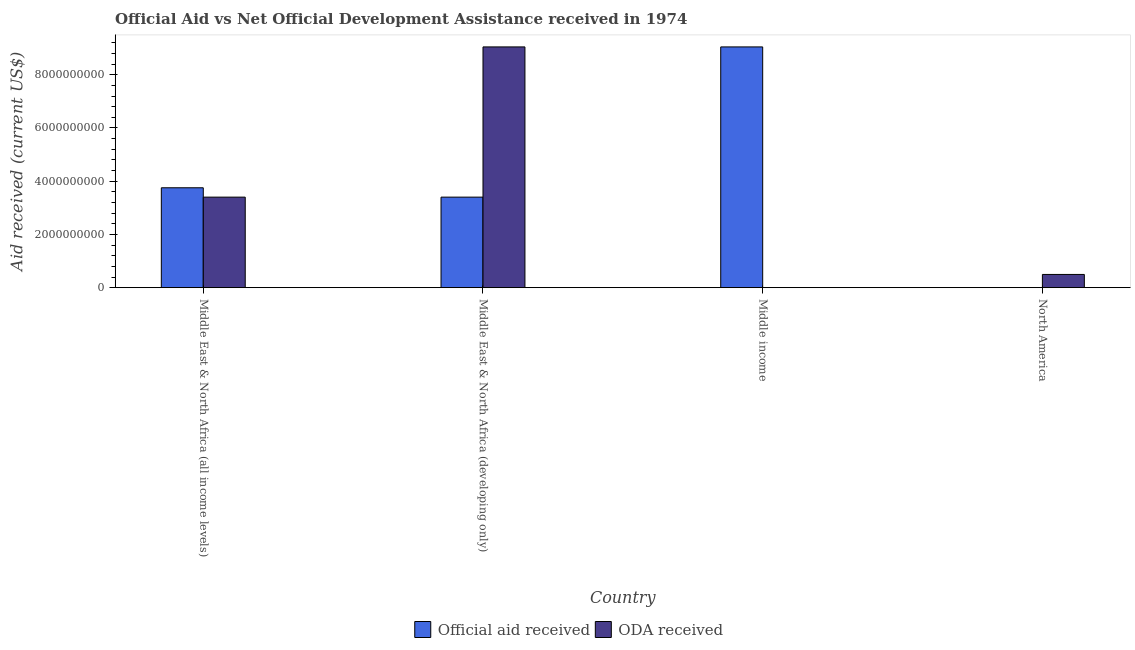How many bars are there on the 2nd tick from the left?
Provide a short and direct response. 2. How many bars are there on the 3rd tick from the right?
Provide a short and direct response. 2. What is the label of the 1st group of bars from the left?
Offer a terse response. Middle East & North Africa (all income levels). What is the oda received in Middle income?
Keep it short and to the point. 3.00e+04. Across all countries, what is the maximum oda received?
Provide a short and direct response. 9.05e+09. Across all countries, what is the minimum oda received?
Your answer should be compact. 3.00e+04. In which country was the oda received maximum?
Ensure brevity in your answer.  Middle East & North Africa (developing only). In which country was the official aid received minimum?
Offer a terse response. North America. What is the total oda received in the graph?
Make the answer very short. 1.29e+1. What is the difference between the official aid received in Middle East & North Africa (all income levels) and that in Middle income?
Ensure brevity in your answer.  -5.29e+09. What is the difference between the oda received in North America and the official aid received in Middle East & North Africa (all income levels)?
Give a very brief answer. -3.26e+09. What is the average official aid received per country?
Your answer should be very brief. 4.05e+09. What is the difference between the official aid received and oda received in North America?
Give a very brief answer. -4.96e+08. In how many countries, is the official aid received greater than 6400000000 US$?
Your answer should be very brief. 1. What is the ratio of the official aid received in Middle East & North Africa (all income levels) to that in Middle income?
Provide a succinct answer. 0.41. Is the difference between the oda received in Middle East & North Africa (all income levels) and Middle income greater than the difference between the official aid received in Middle East & North Africa (all income levels) and Middle income?
Give a very brief answer. Yes. What is the difference between the highest and the second highest official aid received?
Your answer should be compact. 5.29e+09. What is the difference between the highest and the lowest official aid received?
Provide a short and direct response. 9.05e+09. Is the sum of the oda received in Middle East & North Africa (all income levels) and North America greater than the maximum official aid received across all countries?
Provide a short and direct response. No. What does the 1st bar from the left in Middle East & North Africa (all income levels) represents?
Provide a short and direct response. Official aid received. What does the 2nd bar from the right in North America represents?
Your answer should be very brief. Official aid received. How many countries are there in the graph?
Offer a very short reply. 4. Does the graph contain grids?
Offer a very short reply. No. Where does the legend appear in the graph?
Keep it short and to the point. Bottom center. How many legend labels are there?
Offer a terse response. 2. What is the title of the graph?
Your answer should be very brief. Official Aid vs Net Official Development Assistance received in 1974 . Does "Non-solid fuel" appear as one of the legend labels in the graph?
Make the answer very short. No. What is the label or title of the X-axis?
Keep it short and to the point. Country. What is the label or title of the Y-axis?
Provide a succinct answer. Aid received (current US$). What is the Aid received (current US$) in Official aid received in Middle East & North Africa (all income levels)?
Your response must be concise. 3.75e+09. What is the Aid received (current US$) of ODA received in Middle East & North Africa (all income levels)?
Provide a succinct answer. 3.40e+09. What is the Aid received (current US$) of Official aid received in Middle East & North Africa (developing only)?
Offer a terse response. 3.40e+09. What is the Aid received (current US$) in ODA received in Middle East & North Africa (developing only)?
Offer a terse response. 9.05e+09. What is the Aid received (current US$) of Official aid received in Middle income?
Make the answer very short. 9.05e+09. What is the Aid received (current US$) of ODA received in North America?
Your response must be concise. 4.96e+08. Across all countries, what is the maximum Aid received (current US$) of Official aid received?
Offer a very short reply. 9.05e+09. Across all countries, what is the maximum Aid received (current US$) in ODA received?
Offer a terse response. 9.05e+09. What is the total Aid received (current US$) of Official aid received in the graph?
Your answer should be very brief. 1.62e+1. What is the total Aid received (current US$) in ODA received in the graph?
Your answer should be very brief. 1.29e+1. What is the difference between the Aid received (current US$) in Official aid received in Middle East & North Africa (all income levels) and that in Middle East & North Africa (developing only)?
Your answer should be very brief. 3.52e+08. What is the difference between the Aid received (current US$) in ODA received in Middle East & North Africa (all income levels) and that in Middle East & North Africa (developing only)?
Ensure brevity in your answer.  -5.64e+09. What is the difference between the Aid received (current US$) in Official aid received in Middle East & North Africa (all income levels) and that in Middle income?
Your answer should be very brief. -5.29e+09. What is the difference between the Aid received (current US$) of ODA received in Middle East & North Africa (all income levels) and that in Middle income?
Your answer should be compact. 3.40e+09. What is the difference between the Aid received (current US$) in Official aid received in Middle East & North Africa (all income levels) and that in North America?
Offer a terse response. 3.75e+09. What is the difference between the Aid received (current US$) in ODA received in Middle East & North Africa (all income levels) and that in North America?
Keep it short and to the point. 2.91e+09. What is the difference between the Aid received (current US$) in Official aid received in Middle East & North Africa (developing only) and that in Middle income?
Your answer should be very brief. -5.64e+09. What is the difference between the Aid received (current US$) in ODA received in Middle East & North Africa (developing only) and that in Middle income?
Keep it short and to the point. 9.05e+09. What is the difference between the Aid received (current US$) of Official aid received in Middle East & North Africa (developing only) and that in North America?
Your answer should be compact. 3.40e+09. What is the difference between the Aid received (current US$) in ODA received in Middle East & North Africa (developing only) and that in North America?
Ensure brevity in your answer.  8.55e+09. What is the difference between the Aid received (current US$) in Official aid received in Middle income and that in North America?
Your answer should be compact. 9.05e+09. What is the difference between the Aid received (current US$) of ODA received in Middle income and that in North America?
Your answer should be compact. -4.96e+08. What is the difference between the Aid received (current US$) of Official aid received in Middle East & North Africa (all income levels) and the Aid received (current US$) of ODA received in Middle East & North Africa (developing only)?
Keep it short and to the point. -5.29e+09. What is the difference between the Aid received (current US$) of Official aid received in Middle East & North Africa (all income levels) and the Aid received (current US$) of ODA received in Middle income?
Provide a succinct answer. 3.75e+09. What is the difference between the Aid received (current US$) of Official aid received in Middle East & North Africa (all income levels) and the Aid received (current US$) of ODA received in North America?
Provide a short and direct response. 3.26e+09. What is the difference between the Aid received (current US$) in Official aid received in Middle East & North Africa (developing only) and the Aid received (current US$) in ODA received in Middle income?
Keep it short and to the point. 3.40e+09. What is the difference between the Aid received (current US$) in Official aid received in Middle East & North Africa (developing only) and the Aid received (current US$) in ODA received in North America?
Give a very brief answer. 2.91e+09. What is the difference between the Aid received (current US$) in Official aid received in Middle income and the Aid received (current US$) in ODA received in North America?
Ensure brevity in your answer.  8.55e+09. What is the average Aid received (current US$) of Official aid received per country?
Offer a very short reply. 4.05e+09. What is the average Aid received (current US$) in ODA received per country?
Keep it short and to the point. 3.24e+09. What is the difference between the Aid received (current US$) of Official aid received and Aid received (current US$) of ODA received in Middle East & North Africa (all income levels)?
Offer a very short reply. 3.52e+08. What is the difference between the Aid received (current US$) in Official aid received and Aid received (current US$) in ODA received in Middle East & North Africa (developing only)?
Your answer should be very brief. -5.64e+09. What is the difference between the Aid received (current US$) of Official aid received and Aid received (current US$) of ODA received in Middle income?
Ensure brevity in your answer.  9.05e+09. What is the difference between the Aid received (current US$) in Official aid received and Aid received (current US$) in ODA received in North America?
Keep it short and to the point. -4.96e+08. What is the ratio of the Aid received (current US$) of Official aid received in Middle East & North Africa (all income levels) to that in Middle East & North Africa (developing only)?
Offer a terse response. 1.1. What is the ratio of the Aid received (current US$) in ODA received in Middle East & North Africa (all income levels) to that in Middle East & North Africa (developing only)?
Your answer should be compact. 0.38. What is the ratio of the Aid received (current US$) of Official aid received in Middle East & North Africa (all income levels) to that in Middle income?
Your answer should be very brief. 0.41. What is the ratio of the Aid received (current US$) of ODA received in Middle East & North Africa (all income levels) to that in Middle income?
Your response must be concise. 1.13e+05. What is the ratio of the Aid received (current US$) in Official aid received in Middle East & North Africa (all income levels) to that in North America?
Provide a short and direct response. 1.25e+05. What is the ratio of the Aid received (current US$) in ODA received in Middle East & North Africa (all income levels) to that in North America?
Your response must be concise. 6.85. What is the ratio of the Aid received (current US$) of Official aid received in Middle East & North Africa (developing only) to that in Middle income?
Your answer should be compact. 0.38. What is the ratio of the Aid received (current US$) in ODA received in Middle East & North Africa (developing only) to that in Middle income?
Your answer should be compact. 3.02e+05. What is the ratio of the Aid received (current US$) in Official aid received in Middle East & North Africa (developing only) to that in North America?
Your answer should be very brief. 1.13e+05. What is the ratio of the Aid received (current US$) in ODA received in Middle East & North Africa (developing only) to that in North America?
Your answer should be compact. 18.22. What is the ratio of the Aid received (current US$) of Official aid received in Middle income to that in North America?
Your response must be concise. 3.02e+05. What is the difference between the highest and the second highest Aid received (current US$) of Official aid received?
Provide a short and direct response. 5.29e+09. What is the difference between the highest and the second highest Aid received (current US$) in ODA received?
Your answer should be compact. 5.64e+09. What is the difference between the highest and the lowest Aid received (current US$) in Official aid received?
Offer a terse response. 9.05e+09. What is the difference between the highest and the lowest Aid received (current US$) in ODA received?
Your response must be concise. 9.05e+09. 